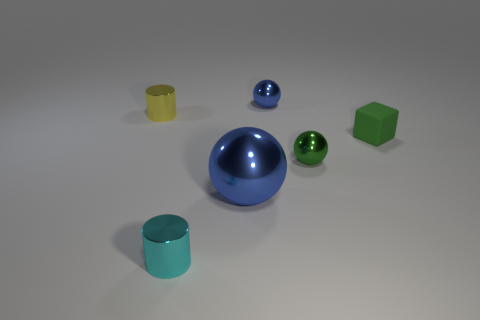Add 4 cyan cylinders. How many objects exist? 10 Subtract all cylinders. How many objects are left? 4 Subtract 0 brown cylinders. How many objects are left? 6 Subtract all brown shiny things. Subtract all green rubber blocks. How many objects are left? 5 Add 2 small yellow shiny cylinders. How many small yellow shiny cylinders are left? 3 Add 2 cyan cylinders. How many cyan cylinders exist? 3 